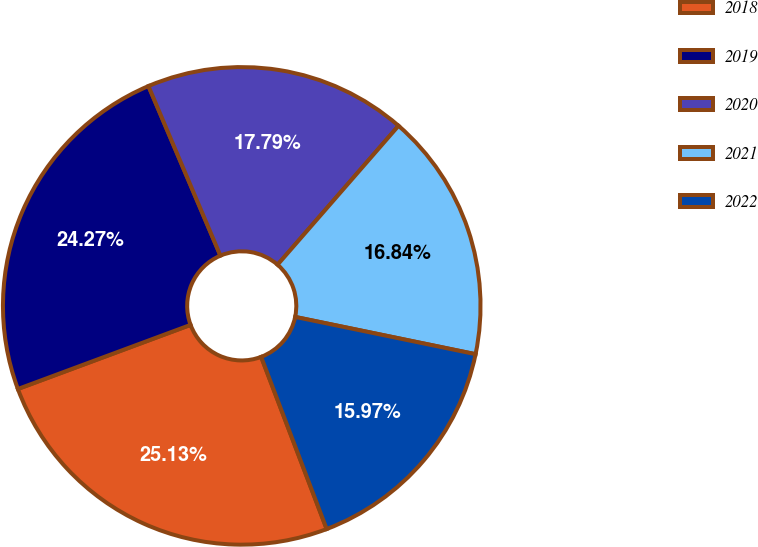<chart> <loc_0><loc_0><loc_500><loc_500><pie_chart><fcel>2018<fcel>2019<fcel>2020<fcel>2021<fcel>2022<nl><fcel>25.13%<fcel>24.27%<fcel>17.79%<fcel>16.84%<fcel>15.97%<nl></chart> 